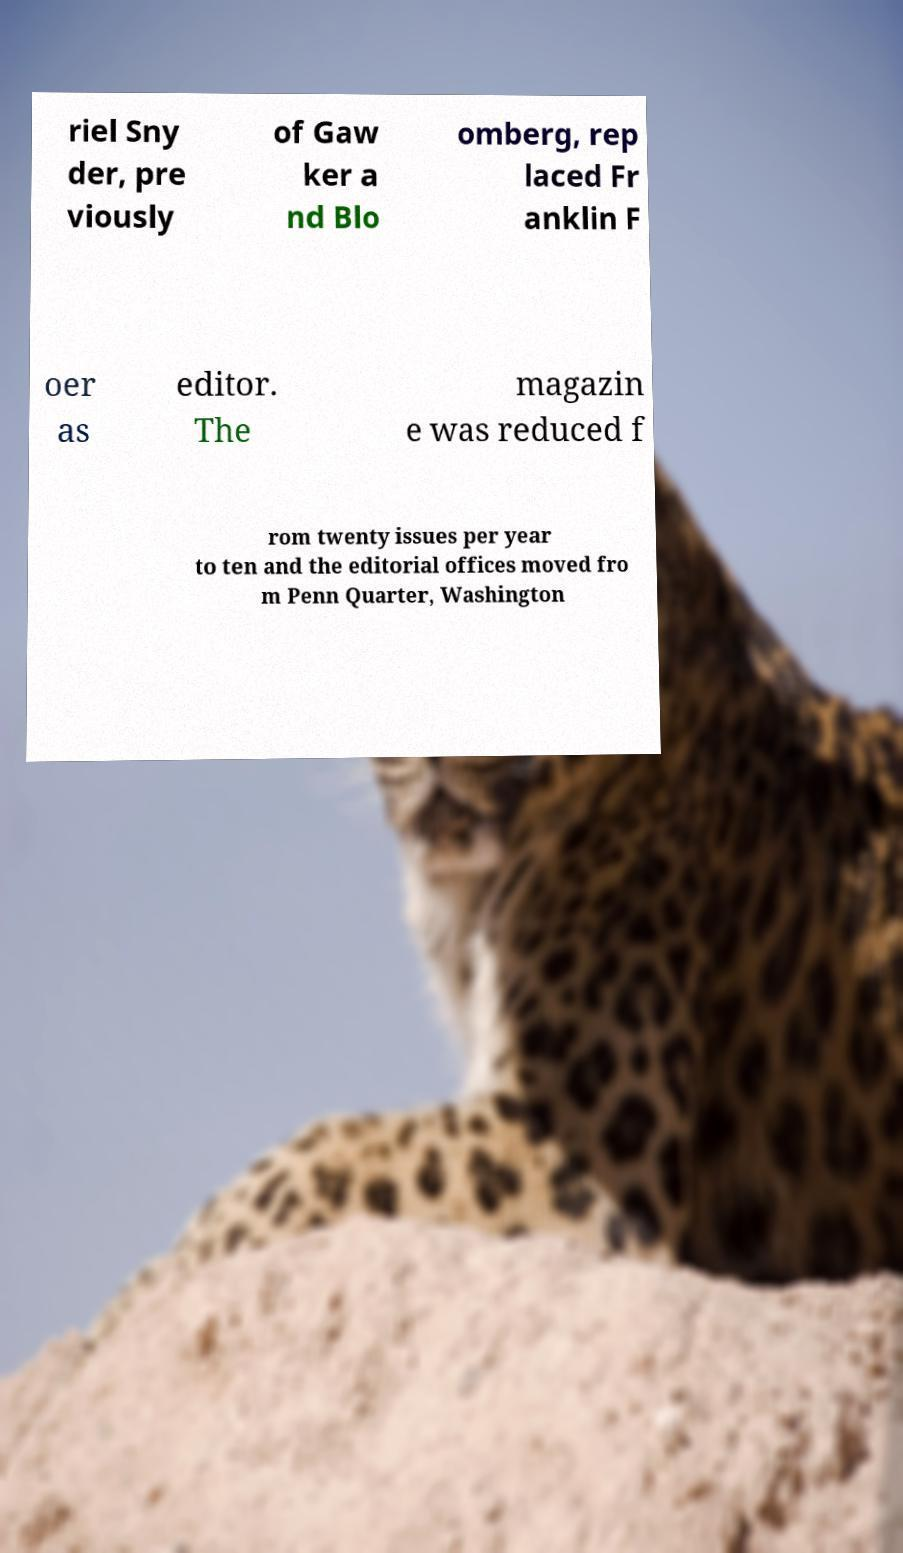I need the written content from this picture converted into text. Can you do that? riel Sny der, pre viously of Gaw ker a nd Blo omberg, rep laced Fr anklin F oer as editor. The magazin e was reduced f rom twenty issues per year to ten and the editorial offices moved fro m Penn Quarter, Washington 